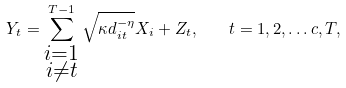Convert formula to latex. <formula><loc_0><loc_0><loc_500><loc_500>Y _ { t } = \sum _ { \substack { i = 1 \\ i \neq t } } ^ { T - 1 } \sqrt { \kappa d _ { i t } ^ { - \eta } } X _ { i } + Z _ { t } , \quad t = 1 , 2 , \dots c , T ,</formula> 